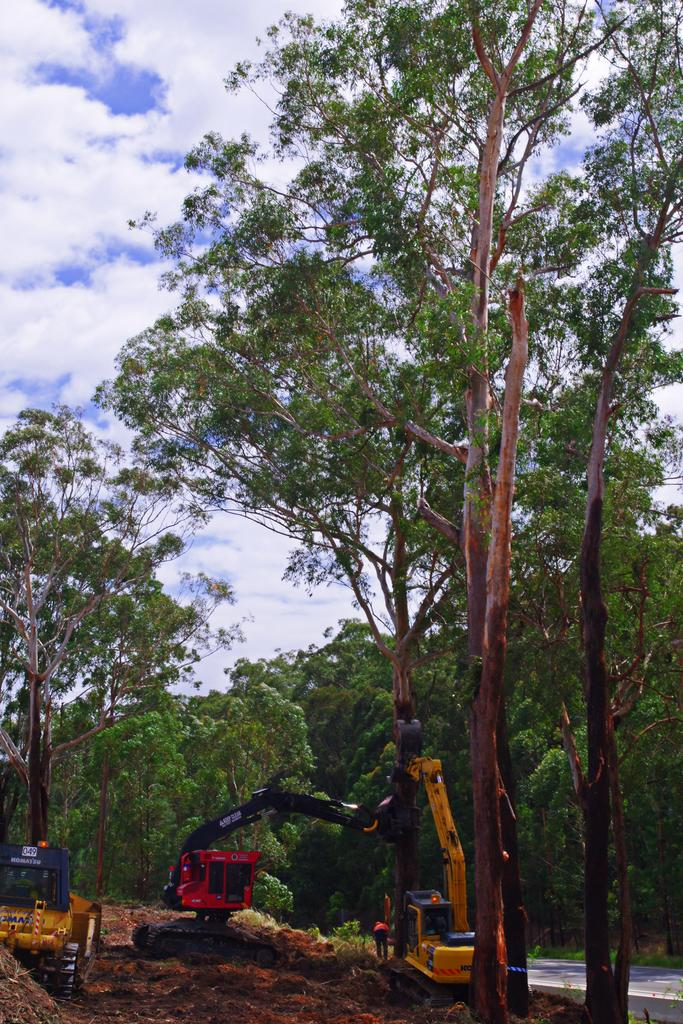What type of machinery can be seen in the image? There are mobile cranes in the image. What natural elements are present in the image? There are many trees in the image. What is visible in the background of the image? The sky is visible in the image. What atmospheric conditions can be observed in the sky? Clouds are present in the sky. What type of plastic material can be seen on the farm in the image? There is no farm or plastic material present in the image. 